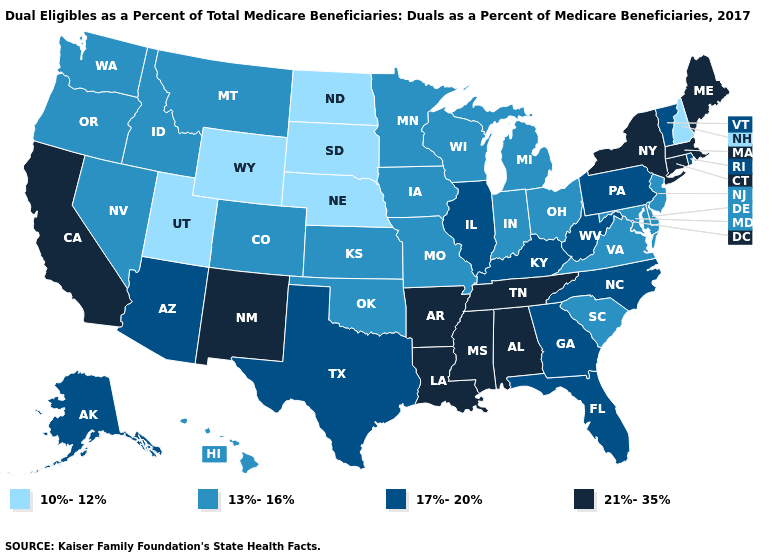Does the map have missing data?
Concise answer only. No. Which states have the highest value in the USA?
Write a very short answer. Alabama, Arkansas, California, Connecticut, Louisiana, Maine, Massachusetts, Mississippi, New Mexico, New York, Tennessee. Does Nebraska have the lowest value in the MidWest?
Short answer required. Yes. Does Georgia have the highest value in the USA?
Answer briefly. No. What is the value of Louisiana?
Short answer required. 21%-35%. What is the lowest value in the USA?
Concise answer only. 10%-12%. Among the states that border North Carolina , which have the lowest value?
Write a very short answer. South Carolina, Virginia. How many symbols are there in the legend?
Keep it brief. 4. Which states have the lowest value in the USA?
Short answer required. Nebraska, New Hampshire, North Dakota, South Dakota, Utah, Wyoming. Does Nebraska have the lowest value in the MidWest?
Quick response, please. Yes. Among the states that border Mississippi , which have the highest value?
Be succinct. Alabama, Arkansas, Louisiana, Tennessee. What is the value of Washington?
Short answer required. 13%-16%. What is the value of Kentucky?
Answer briefly. 17%-20%. What is the value of Iowa?
Short answer required. 13%-16%. 